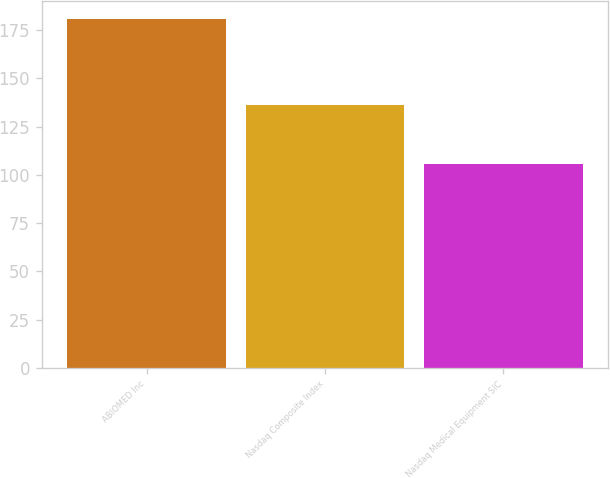Convert chart to OTSL. <chart><loc_0><loc_0><loc_500><loc_500><bar_chart><fcel>ABIOMED Inc<fcel>Nasdaq Composite Index<fcel>Nasdaq Medical Equipment SIC<nl><fcel>180.91<fcel>136.26<fcel>105.56<nl></chart> 